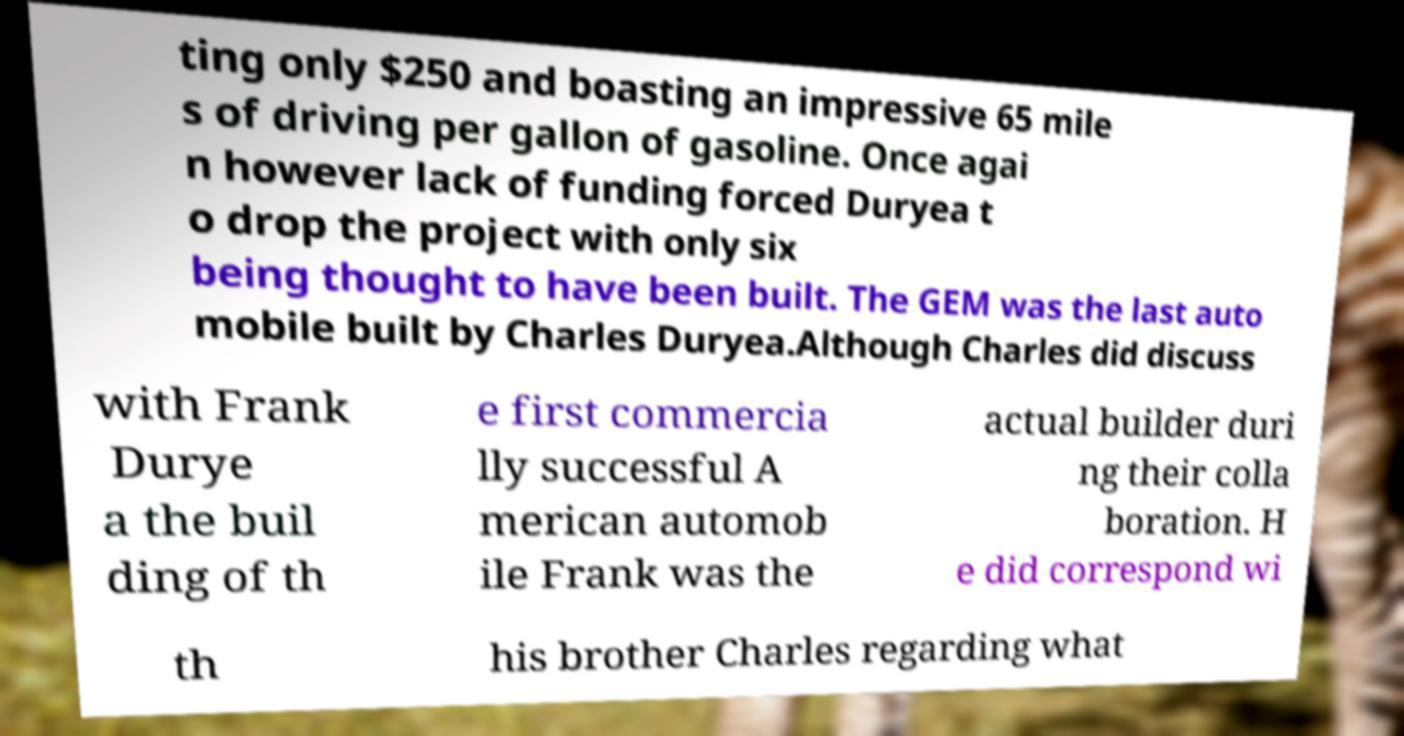Please identify and transcribe the text found in this image. ting only $250 and boasting an impressive 65 mile s of driving per gallon of gasoline. Once agai n however lack of funding forced Duryea t o drop the project with only six being thought to have been built. The GEM was the last auto mobile built by Charles Duryea.Although Charles did discuss with Frank Durye a the buil ding of th e first commercia lly successful A merican automob ile Frank was the actual builder duri ng their colla boration. H e did correspond wi th his brother Charles regarding what 